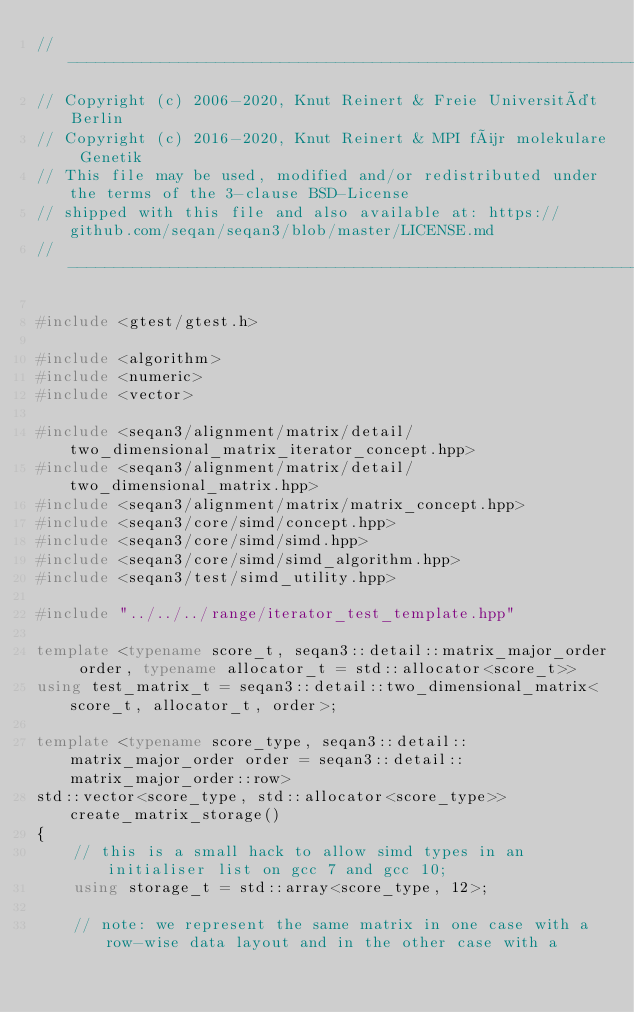Convert code to text. <code><loc_0><loc_0><loc_500><loc_500><_C++_>// -----------------------------------------------------------------------------------------------------
// Copyright (c) 2006-2020, Knut Reinert & Freie Universität Berlin
// Copyright (c) 2016-2020, Knut Reinert & MPI für molekulare Genetik
// This file may be used, modified and/or redistributed under the terms of the 3-clause BSD-License
// shipped with this file and also available at: https://github.com/seqan/seqan3/blob/master/LICENSE.md
// -----------------------------------------------------------------------------------------------------

#include <gtest/gtest.h>

#include <algorithm>
#include <numeric>
#include <vector>

#include <seqan3/alignment/matrix/detail/two_dimensional_matrix_iterator_concept.hpp>
#include <seqan3/alignment/matrix/detail/two_dimensional_matrix.hpp>
#include <seqan3/alignment/matrix/matrix_concept.hpp>
#include <seqan3/core/simd/concept.hpp>
#include <seqan3/core/simd/simd.hpp>
#include <seqan3/core/simd/simd_algorithm.hpp>
#include <seqan3/test/simd_utility.hpp>

#include "../../../range/iterator_test_template.hpp"

template <typename score_t, seqan3::detail::matrix_major_order order, typename allocator_t = std::allocator<score_t>>
using test_matrix_t = seqan3::detail::two_dimensional_matrix<score_t, allocator_t, order>;

template <typename score_type, seqan3::detail::matrix_major_order order = seqan3::detail::matrix_major_order::row>
std::vector<score_type, std::allocator<score_type>> create_matrix_storage()
{
    // this is a small hack to allow simd types in an initialiser list on gcc 7 and gcc 10;
    using storage_t = std::array<score_type, 12>;

    // note: we represent the same matrix in one case with a row-wise data layout and in the other case with a</code> 